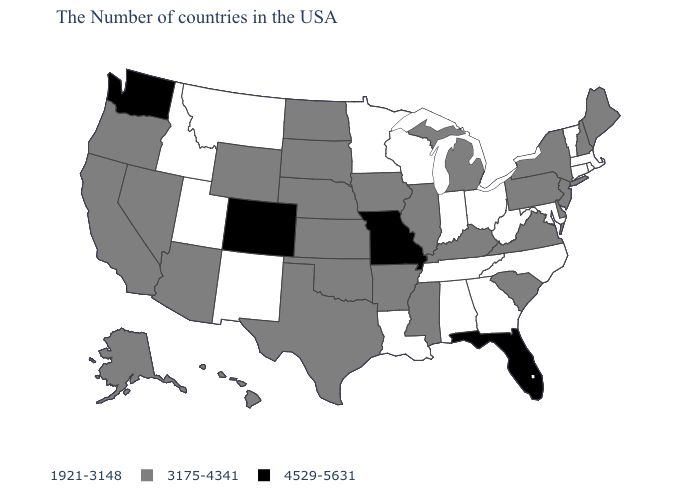How many symbols are there in the legend?
Short answer required. 3. Which states hav the highest value in the South?
Write a very short answer. Florida. Name the states that have a value in the range 4529-5631?
Short answer required. Florida, Missouri, Colorado, Washington. Among the states that border Montana , which have the lowest value?
Write a very short answer. Idaho. How many symbols are there in the legend?
Keep it brief. 3. What is the value of Oregon?
Answer briefly. 3175-4341. What is the value of Maine?
Quick response, please. 3175-4341. Among the states that border North Carolina , which have the highest value?
Quick response, please. Virginia, South Carolina. Name the states that have a value in the range 1921-3148?
Keep it brief. Massachusetts, Rhode Island, Vermont, Connecticut, Maryland, North Carolina, West Virginia, Ohio, Georgia, Indiana, Alabama, Tennessee, Wisconsin, Louisiana, Minnesota, New Mexico, Utah, Montana, Idaho. Does the map have missing data?
Give a very brief answer. No. Which states have the lowest value in the USA?
Quick response, please. Massachusetts, Rhode Island, Vermont, Connecticut, Maryland, North Carolina, West Virginia, Ohio, Georgia, Indiana, Alabama, Tennessee, Wisconsin, Louisiana, Minnesota, New Mexico, Utah, Montana, Idaho. What is the value of West Virginia?
Be succinct. 1921-3148. Name the states that have a value in the range 1921-3148?
Answer briefly. Massachusetts, Rhode Island, Vermont, Connecticut, Maryland, North Carolina, West Virginia, Ohio, Georgia, Indiana, Alabama, Tennessee, Wisconsin, Louisiana, Minnesota, New Mexico, Utah, Montana, Idaho. What is the value of Connecticut?
Answer briefly. 1921-3148. What is the value of Vermont?
Concise answer only. 1921-3148. 